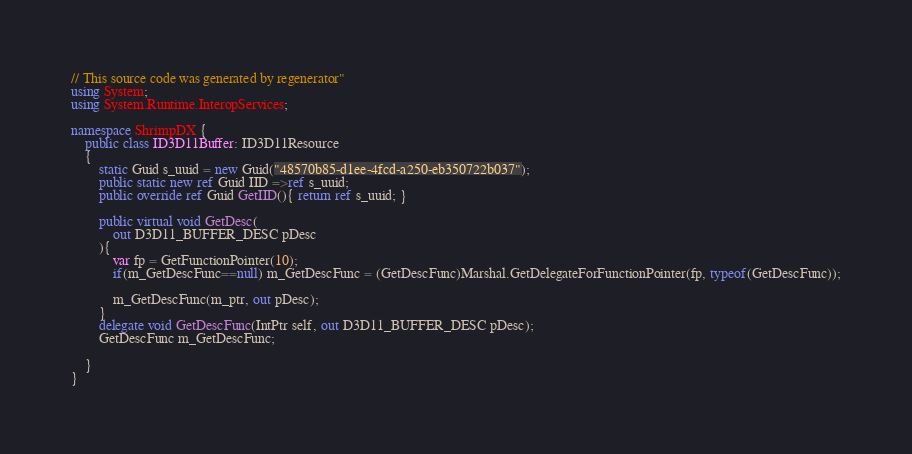<code> <loc_0><loc_0><loc_500><loc_500><_C#_>// This source code was generated by regenerator"
using System;
using System.Runtime.InteropServices;

namespace ShrimpDX {
    public class ID3D11Buffer: ID3D11Resource
    {
        static Guid s_uuid = new Guid("48570b85-d1ee-4fcd-a250-eb350722b037");
        public static new ref Guid IID =>ref s_uuid;
        public override ref Guid GetIID(){ return ref s_uuid; }
                
        public virtual void GetDesc(
            out D3D11_BUFFER_DESC pDesc
        ){
            var fp = GetFunctionPointer(10);
            if(m_GetDescFunc==null) m_GetDescFunc = (GetDescFunc)Marshal.GetDelegateForFunctionPointer(fp, typeof(GetDescFunc));
            
            m_GetDescFunc(m_ptr, out pDesc);
        }
        delegate void GetDescFunc(IntPtr self, out D3D11_BUFFER_DESC pDesc);
        GetDescFunc m_GetDescFunc;

    }
}
</code> 